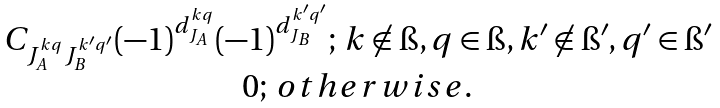<formula> <loc_0><loc_0><loc_500><loc_500>\begin{matrix} C _ { J ^ { k q } _ { A } J ^ { k ^ { \prime } q ^ { \prime } } _ { B } } ( - 1 ) ^ { d ^ { k q } _ { J _ { A } } } ( - 1 ) ^ { d ^ { k ^ { \prime } q ^ { \prime } } _ { J _ { B } } } ; \, k \not \in \i , q \in \i , k ^ { \prime } \not \in \i ^ { \prime } , q ^ { \prime } \in \i ^ { \prime } \\ 0 ; \, { o t h e r w i s e } . \end{matrix}</formula> 